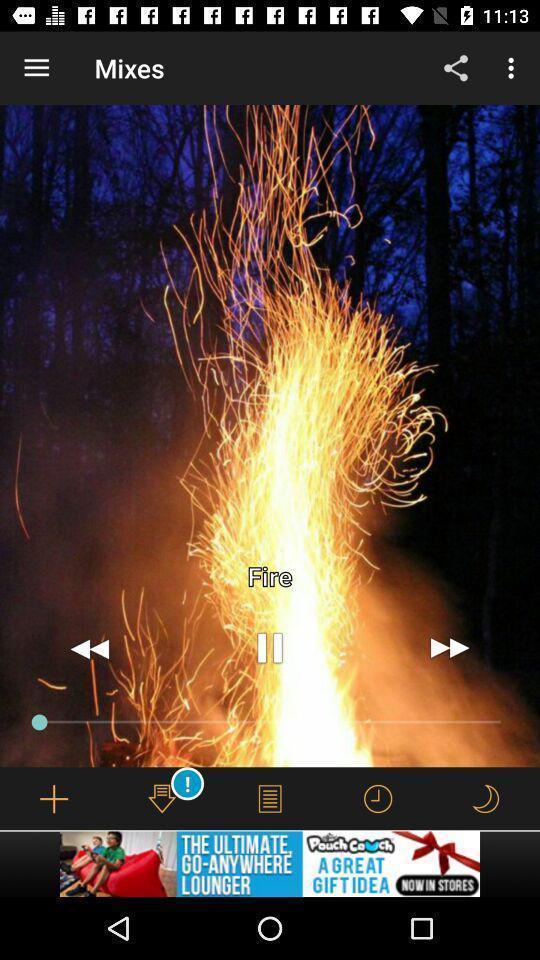Give me a summary of this screen capture. Page showing the track in music app. 